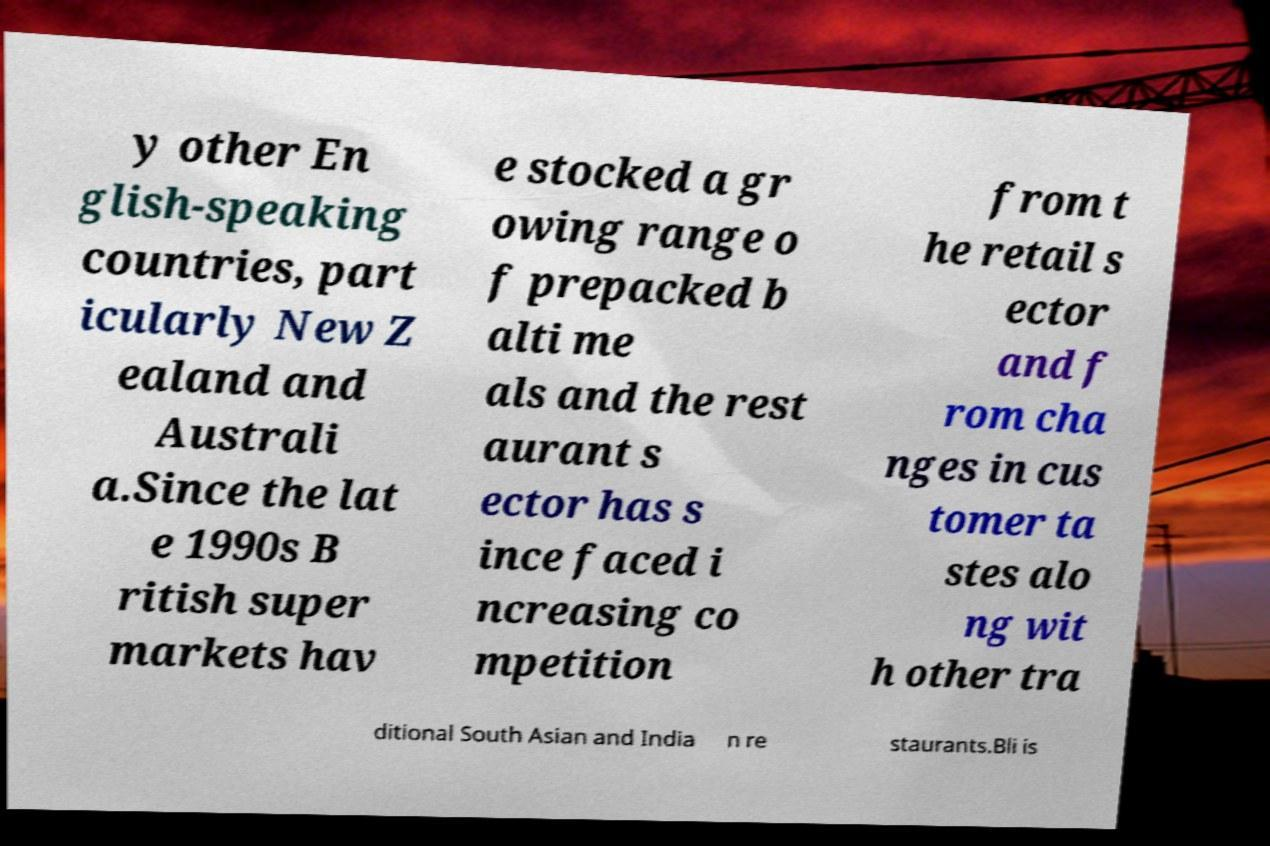Please identify and transcribe the text found in this image. y other En glish-speaking countries, part icularly New Z ealand and Australi a.Since the lat e 1990s B ritish super markets hav e stocked a gr owing range o f prepacked b alti me als and the rest aurant s ector has s ince faced i ncreasing co mpetition from t he retail s ector and f rom cha nges in cus tomer ta stes alo ng wit h other tra ditional South Asian and India n re staurants.Bli is 